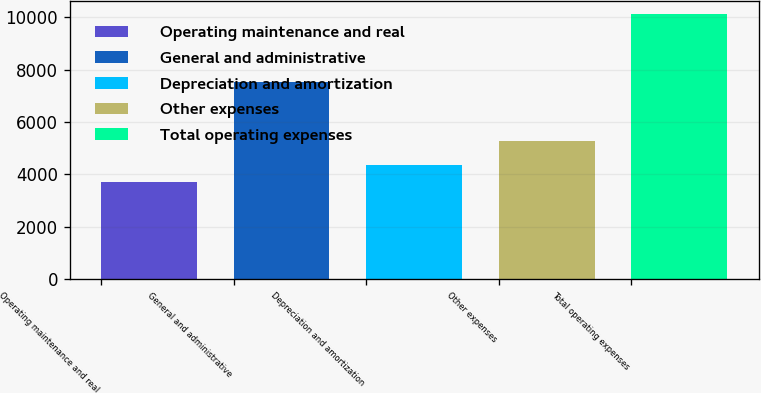Convert chart. <chart><loc_0><loc_0><loc_500><loc_500><bar_chart><fcel>Operating maintenance and real<fcel>General and administrative<fcel>Depreciation and amortization<fcel>Other expenses<fcel>Total operating expenses<nl><fcel>3722<fcel>7533<fcel>4362.4<fcel>5285<fcel>10126<nl></chart> 